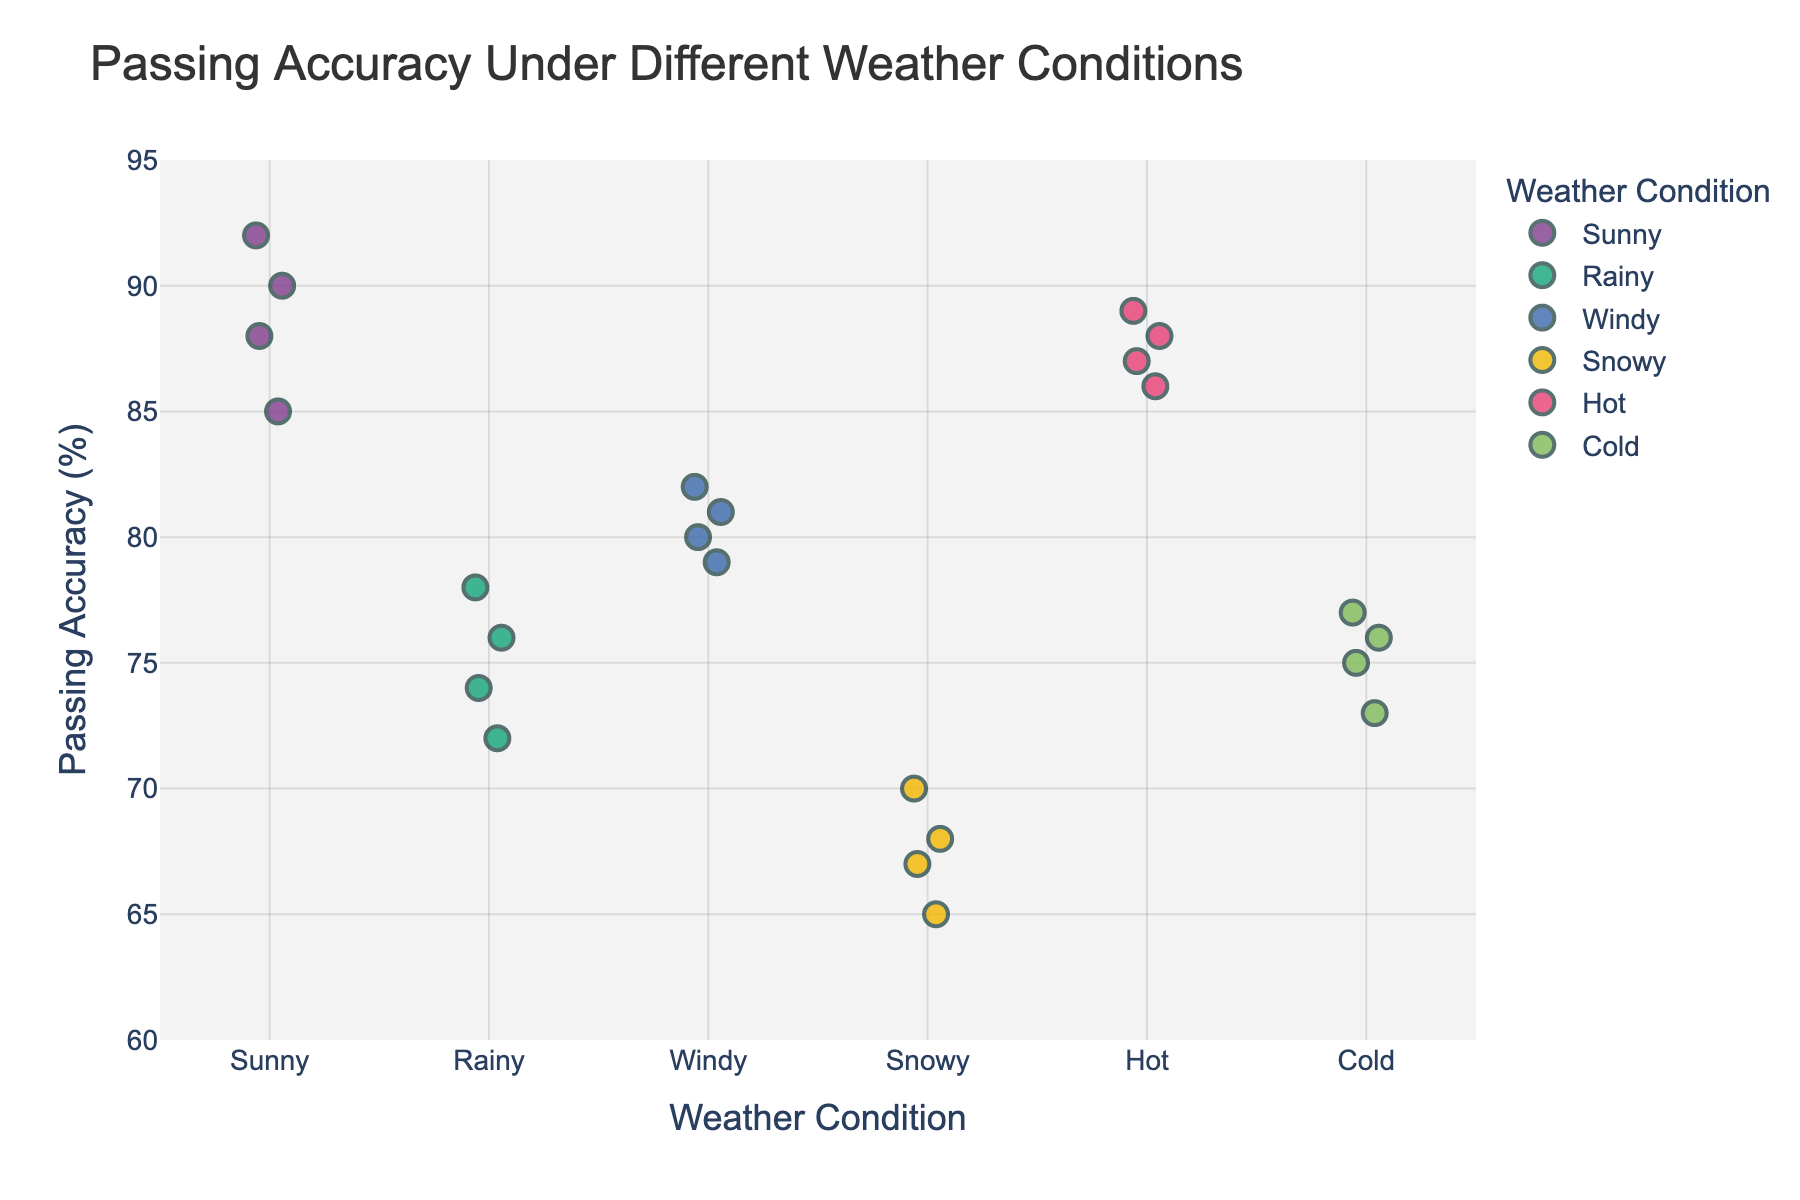What is the title of the figure? The title is usually located at the top of the plot and summarizes what the plot is about. In this case, it is "Passing Accuracy Under Different Weather Conditions."
Answer: "Passing Accuracy Under Different Weather Conditions" What weather condition has the highest passing accuracy score? Look for the highest point on the y-axis and check the corresponding weather condition on the x-axis. The highest score is 92% under Sunny weather.
Answer: Sunny Which weather condition shows the lowest passing accuracy score? Identify the lowest point on the y-axis and determine its x-axis label. The lowest score is 65% under Snowy conditions.
Answer: Snowy How many data points are there in each weather condition? Count the number of markers under each weather condition label on the x-axis. Each condition has four data points.
Answer: 4 What is the average passing accuracy score for Rainy weather conditions? Sum the scores for Rainy weather (76 + 72 + 78 + 74 = 300) and divide by the number of data points (4). The average passing score is 300/4 = 75%.
Answer: 75% Compare the average passing accuracy in Sunny and Rainy weather conditions. Which is higher and by how much? Calculate both averages: Sunny (85 + 88 + 92 + 90 = 355, average = 355/4 = 88.75), Rainy (76 + 72 + 78 + 74 = 300, average = 300/4 = 75), then find the difference 88.75 - 75 = 13.75. Sunny is higher by 13.75%.
Answer: Sunny by 13.75% Is there more variation in passing accuracy scores in Snowy or Windy weather conditions? Compare the spread of data points for Snowy and Windy. Snowy points range from 65 to 70 (a 5-point spread), while Windy points range from 79 to 82 (a 3-point spread). Snowy has more variation.
Answer: Snowy What is the median passing accuracy score for Cold weather conditions? List the scores for Cold weather (73, 75, 76, 77) and find the median. The middle two numbers are 75 and 76, so the median is (75 + 76)/2 = 75.5%.
Answer: 75.5% How does Hot weather affect passing accuracy compared to Cold weather? Calculate the average for both: Hot (87 + 89 + 86 + 88 = 350/4 = 87.5), Cold (73 + 75 + 77 + 76 = 301/4 = 75.25), then compare. Hot is higher by 87.5 - 75.25 = 12.25%.
Answer: Hot is 12.25% higher What is the range of passing accuracy scores for each weather condition? Find the difference between the highest and lowest scores for each condition:
- Sunny: 92 - 85 = 7
- Rainy: 78 - 72 = 6
- Windy: 82 - 79 = 3
- Snowy: 70 - 65 = 5
- Hot: 89 - 86 = 3 
- Cold: 77 - 73 = 4
Answer: Sunny: 7, Rainy: 6, Windy: 3, Snowy: 5, Hot: 3, Cold: 4 